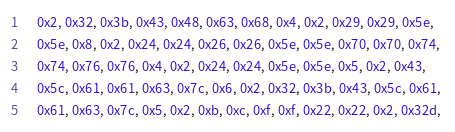Convert code to text. <code><loc_0><loc_0><loc_500><loc_500><_C++_>    0x2, 0x32, 0x3b, 0x43, 0x48, 0x63, 0x68, 0x4, 0x2, 0x29, 0x29, 0x5e, 
    0x5e, 0x8, 0x2, 0x24, 0x24, 0x26, 0x26, 0x5e, 0x5e, 0x70, 0x70, 0x74, 
    0x74, 0x76, 0x76, 0x4, 0x2, 0x24, 0x24, 0x5e, 0x5e, 0x5, 0x2, 0x43, 
    0x5c, 0x61, 0x61, 0x63, 0x7c, 0x6, 0x2, 0x32, 0x3b, 0x43, 0x5c, 0x61, 
    0x61, 0x63, 0x7c, 0x5, 0x2, 0xb, 0xc, 0xf, 0xf, 0x22, 0x22, 0x2, 0x32d, </code> 